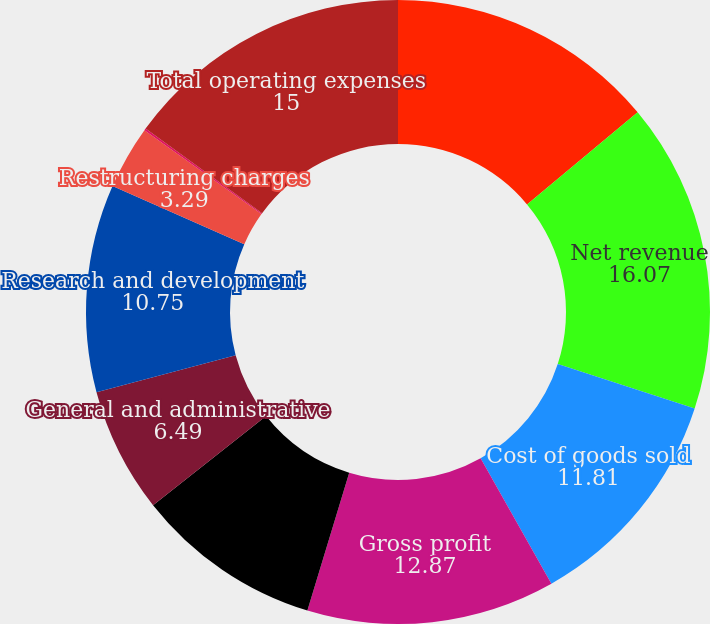<chart> <loc_0><loc_0><loc_500><loc_500><pie_chart><fcel>(In millions except per share<fcel>Net revenue<fcel>Cost of goods sold<fcel>Gross profit<fcel>Marketing and sales<fcel>General and administrative<fcel>Research and development<fcel>Restructuring charges<fcel>Amortization of intangibles<fcel>Total operating expenses<nl><fcel>13.94%<fcel>16.07%<fcel>11.81%<fcel>12.87%<fcel>9.68%<fcel>6.49%<fcel>10.75%<fcel>3.29%<fcel>0.1%<fcel>15.0%<nl></chart> 